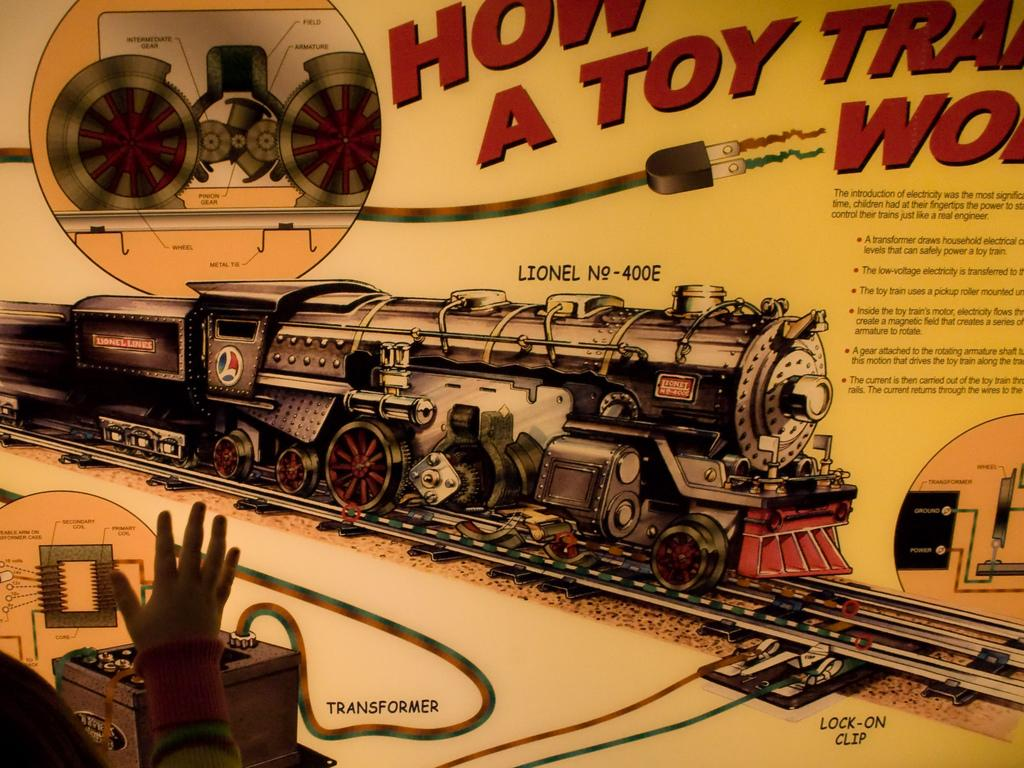What is the main subject of the image? The main subject of the image is a person's hand. What type of image is the person's hand in? The image appears to be a poster. What can be seen on the poster besides the person's hand? There are pictures, numbers, and words on the poster. Can you see a deer in the image? No, there is no deer present in the image. What type of operation is being performed on the table in the image? There is no table or operation present in the image; it features a person's hand on a poster with pictures, numbers, and words. 